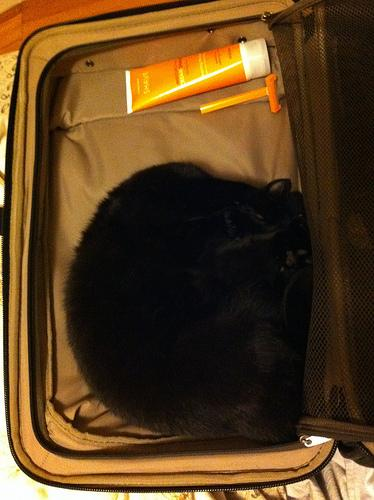What are the colors and physical attributes of the tube and shaver seen in the image? The tube is orange and shiny with a white cap, while the shaver is plastic, orange, and has a disposable razor blade. Describe what the black cat seems to be doing in the image. The black cat appears to be curled up and sleeping inside the open suitcase. Write a short sentence describing the surroundings of the objects in the image. The objects are placed on brown floorboards near some printed gold and white fabric, and rumpled light brown fabric. What items can be seen inside the suitcase? A sleeping black cat, an orange tube with a white cap, and a plastic orange shaver can be seen inside the suitcase. In simple terms, explain the contents of the suitcase. The suitcase contains a black cat, an orange tube, and an orange shaver. Describe the color of the cat and the position it is in. The cat is black and is curled up, sleeping inside the open suitcase. Briefly describe the primary objects in the image. A brown suitcase with black trim and zipper, an orange tube with a white cap, a plastic orange shaver, and a sleeping black cat are in the image. What are the unique features of the suitcase? The suitcase has a brown color, black trim and zipper, black mesh covering on the side, and netting inside the cover. Mention the key properties of the razor and tube in the image. The razor is orange, plastic, and disposable, while the tube is orange, shiny, and has a white cap. What can you say about the materials of various objects in the image? The image shows a brown suitcase with mesh and zipper, an orange plastic tube, an orange plastic shaver, and a furry black cat. 